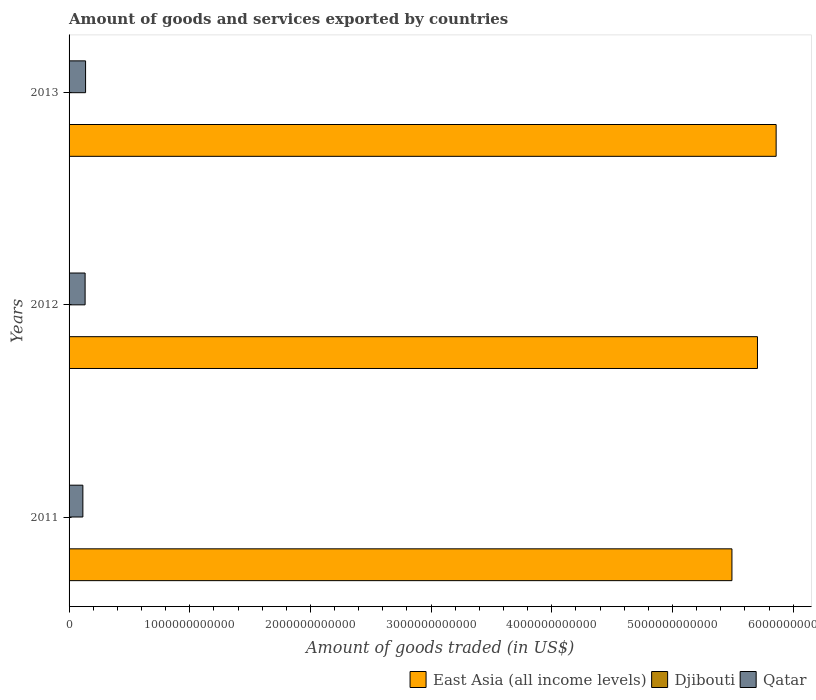How many different coloured bars are there?
Offer a very short reply. 3. How many groups of bars are there?
Provide a short and direct response. 3. Are the number of bars per tick equal to the number of legend labels?
Your answer should be very brief. Yes. Are the number of bars on each tick of the Y-axis equal?
Provide a short and direct response. Yes. How many bars are there on the 3rd tick from the bottom?
Offer a very short reply. 3. What is the label of the 2nd group of bars from the top?
Ensure brevity in your answer.  2012. What is the total amount of goods and services exported in Djibouti in 2013?
Ensure brevity in your answer.  1.13e+08. Across all years, what is the maximum total amount of goods and services exported in East Asia (all income levels)?
Your response must be concise. 5.86e+12. Across all years, what is the minimum total amount of goods and services exported in Djibouti?
Your answer should be very brief. 8.50e+07. In which year was the total amount of goods and services exported in Qatar maximum?
Your answer should be very brief. 2013. In which year was the total amount of goods and services exported in Qatar minimum?
Offer a very short reply. 2011. What is the total total amount of goods and services exported in Djibouti in the graph?
Offer a very short reply. 3.09e+08. What is the difference between the total amount of goods and services exported in East Asia (all income levels) in 2012 and that in 2013?
Provide a short and direct response. -1.55e+11. What is the difference between the total amount of goods and services exported in Qatar in 2011 and the total amount of goods and services exported in East Asia (all income levels) in 2013?
Your answer should be compact. -5.74e+12. What is the average total amount of goods and services exported in Djibouti per year?
Offer a very short reply. 1.03e+08. In the year 2011, what is the difference between the total amount of goods and services exported in East Asia (all income levels) and total amount of goods and services exported in Qatar?
Offer a terse response. 5.38e+12. In how many years, is the total amount of goods and services exported in East Asia (all income levels) greater than 3400000000000 US$?
Your answer should be very brief. 3. What is the ratio of the total amount of goods and services exported in East Asia (all income levels) in 2011 to that in 2013?
Ensure brevity in your answer.  0.94. Is the total amount of goods and services exported in Djibouti in 2011 less than that in 2013?
Offer a very short reply. Yes. What is the difference between the highest and the second highest total amount of goods and services exported in Djibouti?
Make the answer very short. 1.36e+06. What is the difference between the highest and the lowest total amount of goods and services exported in Djibouti?
Your answer should be compact. 2.78e+07. In how many years, is the total amount of goods and services exported in East Asia (all income levels) greater than the average total amount of goods and services exported in East Asia (all income levels) taken over all years?
Give a very brief answer. 2. What does the 1st bar from the top in 2013 represents?
Provide a succinct answer. Qatar. What does the 3rd bar from the bottom in 2012 represents?
Your response must be concise. Qatar. Is it the case that in every year, the sum of the total amount of goods and services exported in Djibouti and total amount of goods and services exported in East Asia (all income levels) is greater than the total amount of goods and services exported in Qatar?
Provide a short and direct response. Yes. Are all the bars in the graph horizontal?
Ensure brevity in your answer.  Yes. How many years are there in the graph?
Give a very brief answer. 3. What is the difference between two consecutive major ticks on the X-axis?
Keep it short and to the point. 1.00e+12. Are the values on the major ticks of X-axis written in scientific E-notation?
Provide a short and direct response. No. Does the graph contain any zero values?
Provide a succinct answer. No. Does the graph contain grids?
Ensure brevity in your answer.  No. Where does the legend appear in the graph?
Keep it short and to the point. Bottom right. What is the title of the graph?
Your answer should be compact. Amount of goods and services exported by countries. What is the label or title of the X-axis?
Provide a short and direct response. Amount of goods traded (in US$). What is the Amount of goods traded (in US$) of East Asia (all income levels) in 2011?
Provide a succinct answer. 5.49e+12. What is the Amount of goods traded (in US$) in Djibouti in 2011?
Ensure brevity in your answer.  8.50e+07. What is the Amount of goods traded (in US$) in Qatar in 2011?
Provide a succinct answer. 1.14e+11. What is the Amount of goods traded (in US$) of East Asia (all income levels) in 2012?
Ensure brevity in your answer.  5.70e+12. What is the Amount of goods traded (in US$) of Djibouti in 2012?
Keep it short and to the point. 1.11e+08. What is the Amount of goods traded (in US$) of Qatar in 2012?
Provide a succinct answer. 1.33e+11. What is the Amount of goods traded (in US$) of East Asia (all income levels) in 2013?
Ensure brevity in your answer.  5.86e+12. What is the Amount of goods traded (in US$) in Djibouti in 2013?
Your answer should be very brief. 1.13e+08. What is the Amount of goods traded (in US$) of Qatar in 2013?
Your answer should be very brief. 1.37e+11. Across all years, what is the maximum Amount of goods traded (in US$) of East Asia (all income levels)?
Provide a succinct answer. 5.86e+12. Across all years, what is the maximum Amount of goods traded (in US$) of Djibouti?
Your answer should be very brief. 1.13e+08. Across all years, what is the maximum Amount of goods traded (in US$) in Qatar?
Ensure brevity in your answer.  1.37e+11. Across all years, what is the minimum Amount of goods traded (in US$) of East Asia (all income levels)?
Your answer should be compact. 5.49e+12. Across all years, what is the minimum Amount of goods traded (in US$) of Djibouti?
Offer a terse response. 8.50e+07. Across all years, what is the minimum Amount of goods traded (in US$) in Qatar?
Make the answer very short. 1.14e+11. What is the total Amount of goods traded (in US$) of East Asia (all income levels) in the graph?
Keep it short and to the point. 1.71e+13. What is the total Amount of goods traded (in US$) in Djibouti in the graph?
Provide a short and direct response. 3.09e+08. What is the total Amount of goods traded (in US$) in Qatar in the graph?
Your answer should be very brief. 3.84e+11. What is the difference between the Amount of goods traded (in US$) in East Asia (all income levels) in 2011 and that in 2012?
Offer a terse response. -2.12e+11. What is the difference between the Amount of goods traded (in US$) in Djibouti in 2011 and that in 2012?
Offer a very short reply. -2.64e+07. What is the difference between the Amount of goods traded (in US$) of Qatar in 2011 and that in 2012?
Keep it short and to the point. -1.85e+1. What is the difference between the Amount of goods traded (in US$) in East Asia (all income levels) in 2011 and that in 2013?
Provide a short and direct response. -3.66e+11. What is the difference between the Amount of goods traded (in US$) in Djibouti in 2011 and that in 2013?
Provide a short and direct response. -2.78e+07. What is the difference between the Amount of goods traded (in US$) of Qatar in 2011 and that in 2013?
Provide a short and direct response. -2.23e+1. What is the difference between the Amount of goods traded (in US$) in East Asia (all income levels) in 2012 and that in 2013?
Keep it short and to the point. -1.55e+11. What is the difference between the Amount of goods traded (in US$) of Djibouti in 2012 and that in 2013?
Give a very brief answer. -1.36e+06. What is the difference between the Amount of goods traded (in US$) in Qatar in 2012 and that in 2013?
Provide a succinct answer. -3.81e+09. What is the difference between the Amount of goods traded (in US$) in East Asia (all income levels) in 2011 and the Amount of goods traded (in US$) in Djibouti in 2012?
Your answer should be compact. 5.49e+12. What is the difference between the Amount of goods traded (in US$) in East Asia (all income levels) in 2011 and the Amount of goods traded (in US$) in Qatar in 2012?
Your answer should be compact. 5.36e+12. What is the difference between the Amount of goods traded (in US$) of Djibouti in 2011 and the Amount of goods traded (in US$) of Qatar in 2012?
Your response must be concise. -1.33e+11. What is the difference between the Amount of goods traded (in US$) in East Asia (all income levels) in 2011 and the Amount of goods traded (in US$) in Djibouti in 2013?
Provide a short and direct response. 5.49e+12. What is the difference between the Amount of goods traded (in US$) in East Asia (all income levels) in 2011 and the Amount of goods traded (in US$) in Qatar in 2013?
Offer a very short reply. 5.36e+12. What is the difference between the Amount of goods traded (in US$) in Djibouti in 2011 and the Amount of goods traded (in US$) in Qatar in 2013?
Offer a very short reply. -1.37e+11. What is the difference between the Amount of goods traded (in US$) of East Asia (all income levels) in 2012 and the Amount of goods traded (in US$) of Djibouti in 2013?
Offer a terse response. 5.70e+12. What is the difference between the Amount of goods traded (in US$) in East Asia (all income levels) in 2012 and the Amount of goods traded (in US$) in Qatar in 2013?
Give a very brief answer. 5.57e+12. What is the difference between the Amount of goods traded (in US$) in Djibouti in 2012 and the Amount of goods traded (in US$) in Qatar in 2013?
Your response must be concise. -1.37e+11. What is the average Amount of goods traded (in US$) of East Asia (all income levels) per year?
Make the answer very short. 5.69e+12. What is the average Amount of goods traded (in US$) in Djibouti per year?
Your response must be concise. 1.03e+08. What is the average Amount of goods traded (in US$) in Qatar per year?
Offer a very short reply. 1.28e+11. In the year 2011, what is the difference between the Amount of goods traded (in US$) of East Asia (all income levels) and Amount of goods traded (in US$) of Djibouti?
Ensure brevity in your answer.  5.49e+12. In the year 2011, what is the difference between the Amount of goods traded (in US$) in East Asia (all income levels) and Amount of goods traded (in US$) in Qatar?
Your answer should be compact. 5.38e+12. In the year 2011, what is the difference between the Amount of goods traded (in US$) of Djibouti and Amount of goods traded (in US$) of Qatar?
Give a very brief answer. -1.14e+11. In the year 2012, what is the difference between the Amount of goods traded (in US$) of East Asia (all income levels) and Amount of goods traded (in US$) of Djibouti?
Provide a succinct answer. 5.70e+12. In the year 2012, what is the difference between the Amount of goods traded (in US$) of East Asia (all income levels) and Amount of goods traded (in US$) of Qatar?
Your answer should be compact. 5.57e+12. In the year 2012, what is the difference between the Amount of goods traded (in US$) in Djibouti and Amount of goods traded (in US$) in Qatar?
Ensure brevity in your answer.  -1.33e+11. In the year 2013, what is the difference between the Amount of goods traded (in US$) of East Asia (all income levels) and Amount of goods traded (in US$) of Djibouti?
Offer a terse response. 5.86e+12. In the year 2013, what is the difference between the Amount of goods traded (in US$) of East Asia (all income levels) and Amount of goods traded (in US$) of Qatar?
Your answer should be very brief. 5.72e+12. In the year 2013, what is the difference between the Amount of goods traded (in US$) in Djibouti and Amount of goods traded (in US$) in Qatar?
Give a very brief answer. -1.37e+11. What is the ratio of the Amount of goods traded (in US$) in East Asia (all income levels) in 2011 to that in 2012?
Your answer should be compact. 0.96. What is the ratio of the Amount of goods traded (in US$) in Djibouti in 2011 to that in 2012?
Offer a very short reply. 0.76. What is the ratio of the Amount of goods traded (in US$) in Qatar in 2011 to that in 2012?
Make the answer very short. 0.86. What is the ratio of the Amount of goods traded (in US$) of Djibouti in 2011 to that in 2013?
Provide a short and direct response. 0.75. What is the ratio of the Amount of goods traded (in US$) in Qatar in 2011 to that in 2013?
Give a very brief answer. 0.84. What is the ratio of the Amount of goods traded (in US$) of East Asia (all income levels) in 2012 to that in 2013?
Provide a short and direct response. 0.97. What is the ratio of the Amount of goods traded (in US$) of Djibouti in 2012 to that in 2013?
Provide a short and direct response. 0.99. What is the ratio of the Amount of goods traded (in US$) of Qatar in 2012 to that in 2013?
Offer a terse response. 0.97. What is the difference between the highest and the second highest Amount of goods traded (in US$) of East Asia (all income levels)?
Give a very brief answer. 1.55e+11. What is the difference between the highest and the second highest Amount of goods traded (in US$) of Djibouti?
Your answer should be compact. 1.36e+06. What is the difference between the highest and the second highest Amount of goods traded (in US$) of Qatar?
Make the answer very short. 3.81e+09. What is the difference between the highest and the lowest Amount of goods traded (in US$) of East Asia (all income levels)?
Your response must be concise. 3.66e+11. What is the difference between the highest and the lowest Amount of goods traded (in US$) of Djibouti?
Ensure brevity in your answer.  2.78e+07. What is the difference between the highest and the lowest Amount of goods traded (in US$) of Qatar?
Your answer should be very brief. 2.23e+1. 